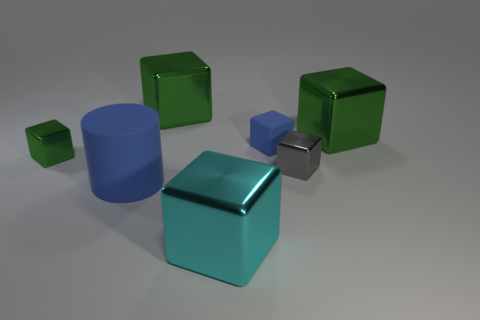Subtract all tiny metal cubes. How many cubes are left? 4 Subtract all green cylinders. How many green cubes are left? 3 Subtract 1 cubes. How many cubes are left? 5 Add 1 green metal cubes. How many objects exist? 8 Subtract all blue cubes. How many cubes are left? 5 Subtract all blocks. How many objects are left? 1 Add 6 tiny blue rubber objects. How many tiny blue rubber objects are left? 7 Add 1 gray metal things. How many gray metal things exist? 2 Subtract 0 brown spheres. How many objects are left? 7 Subtract all purple blocks. Subtract all brown cylinders. How many blocks are left? 6 